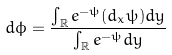<formula> <loc_0><loc_0><loc_500><loc_500>d \phi = \frac { \int _ { \mathbb { R } } e ^ { - \psi } ( d _ { x } { \psi } ) d y } { \int _ { \mathbb { R } } e ^ { - \psi } d y }</formula> 